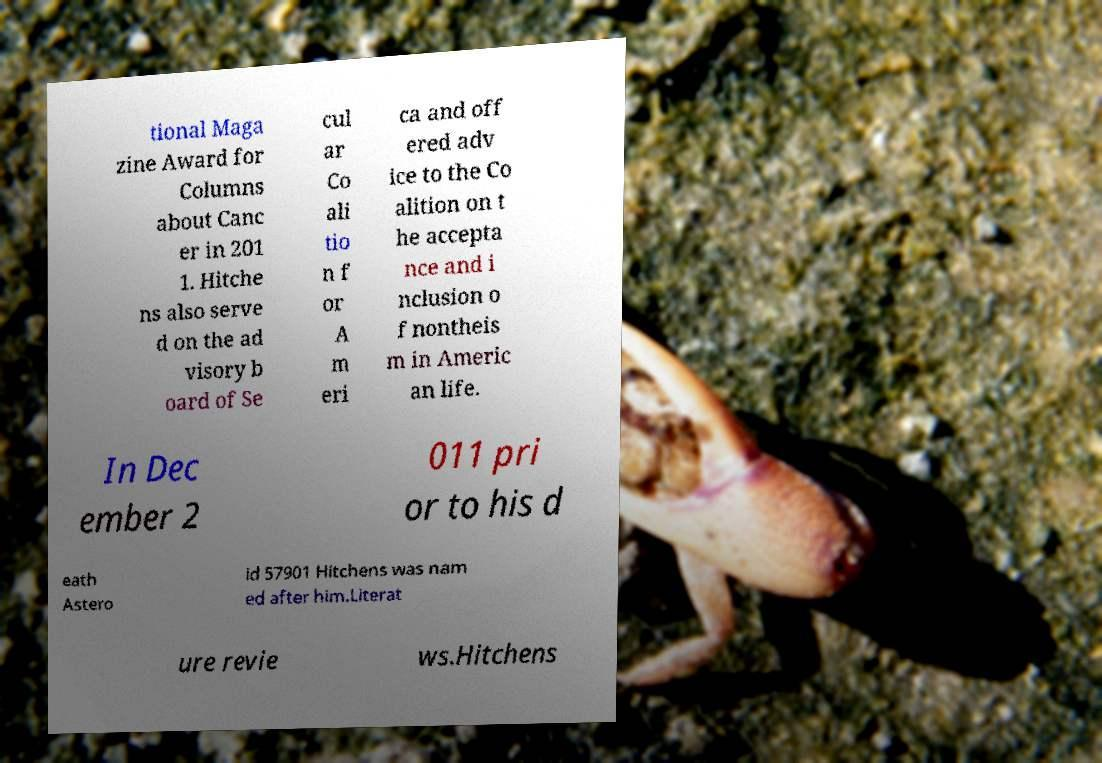There's text embedded in this image that I need extracted. Can you transcribe it verbatim? tional Maga zine Award for Columns about Canc er in 201 1. Hitche ns also serve d on the ad visory b oard of Se cul ar Co ali tio n f or A m eri ca and off ered adv ice to the Co alition on t he accepta nce and i nclusion o f nontheis m in Americ an life. In Dec ember 2 011 pri or to his d eath Astero id 57901 Hitchens was nam ed after him.Literat ure revie ws.Hitchens 